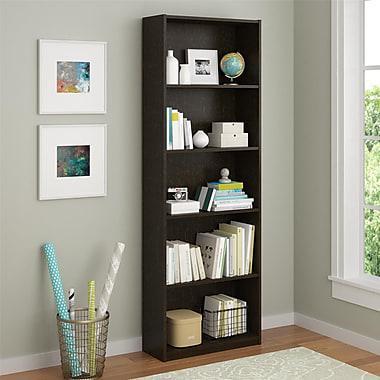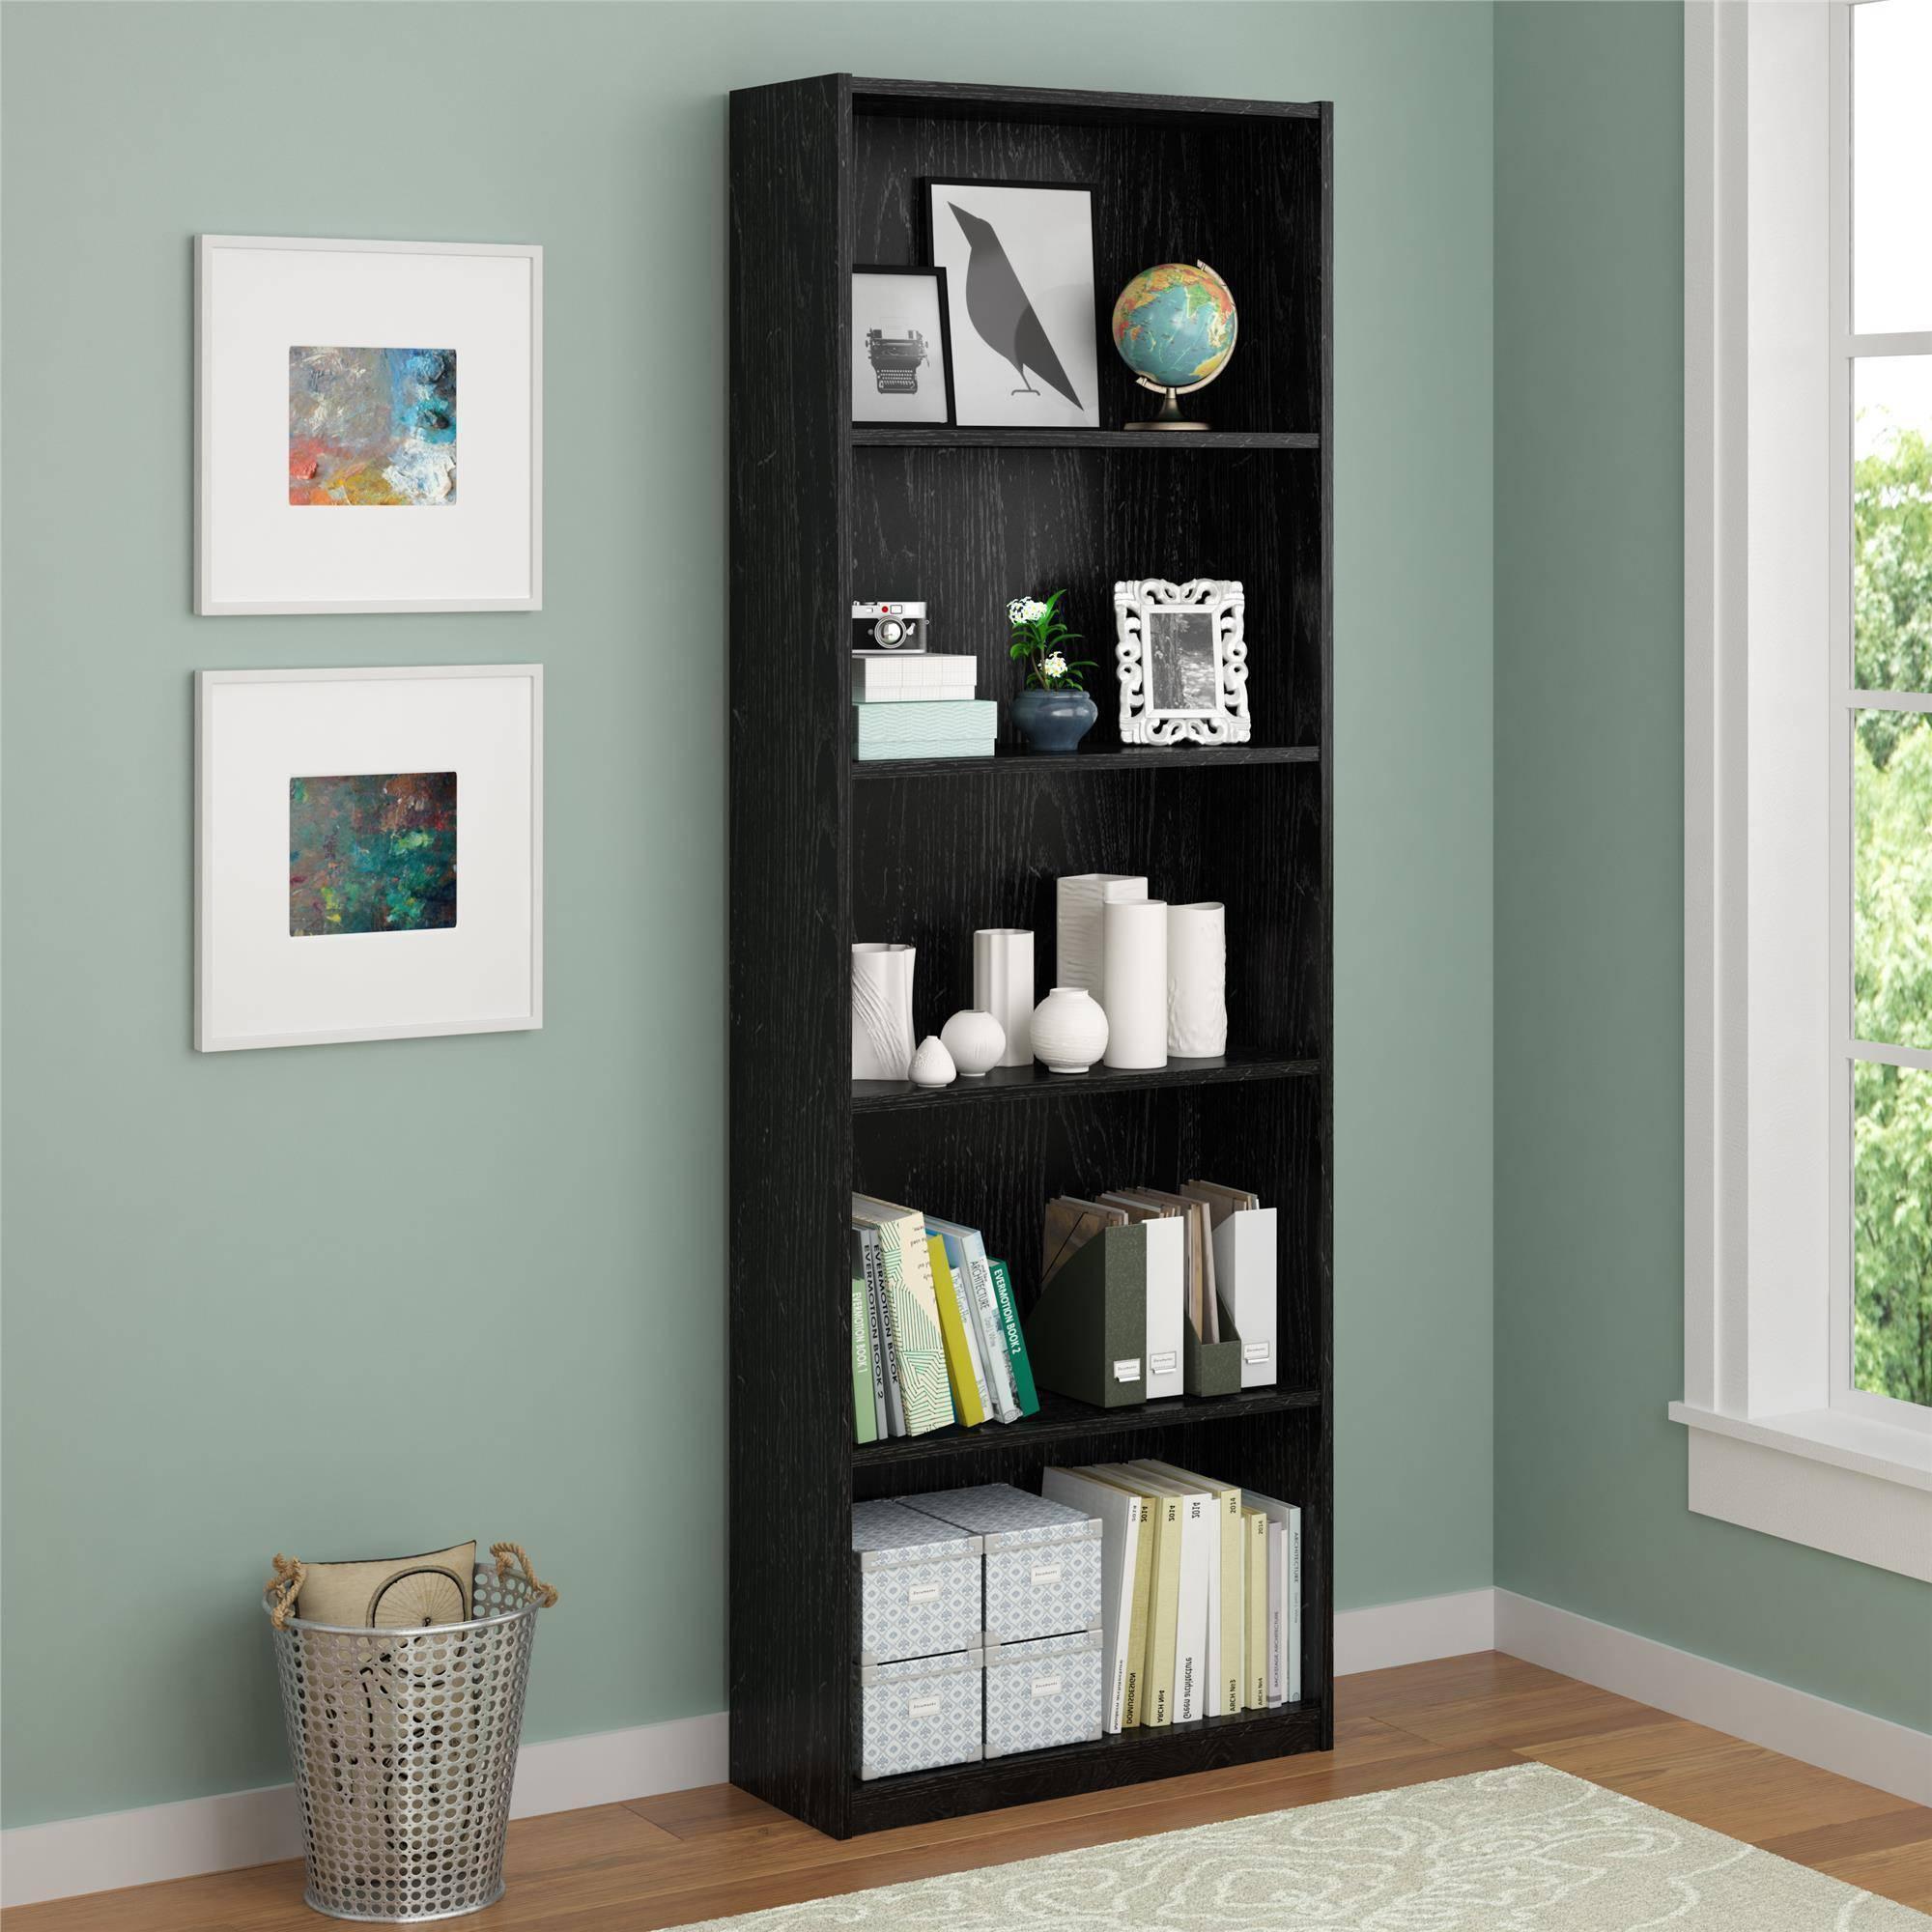The first image is the image on the left, the second image is the image on the right. Assess this claim about the two images: "One of the bookshelves is white.". Correct or not? Answer yes or no. No. 